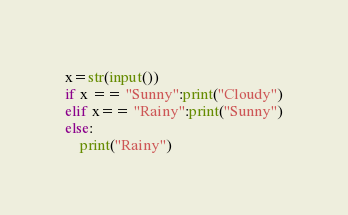Convert code to text. <code><loc_0><loc_0><loc_500><loc_500><_Python_>x=str(input())
if x == "Sunny":print("Cloudy")
elif x== "Rainy":print("Sunny")
else:
    print("Rainy")</code> 